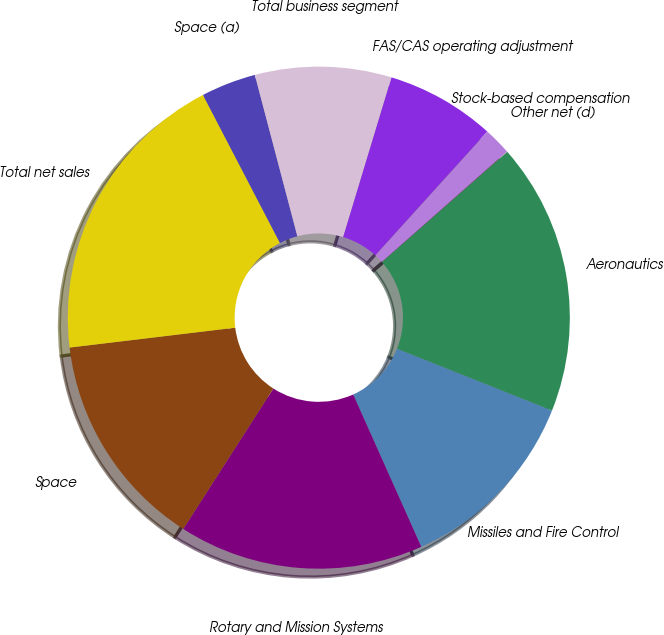<chart> <loc_0><loc_0><loc_500><loc_500><pie_chart><fcel>Aeronautics<fcel>Missiles and Fire Control<fcel>Rotary and Mission Systems<fcel>Space<fcel>Total net sales<fcel>Space (a)<fcel>Total business segment<fcel>FAS/CAS operating adjustment<fcel>Stock-based compensation<fcel>Other net (d)<nl><fcel>17.52%<fcel>12.27%<fcel>15.77%<fcel>14.02%<fcel>19.27%<fcel>3.53%<fcel>8.78%<fcel>7.03%<fcel>1.78%<fcel>0.03%<nl></chart> 